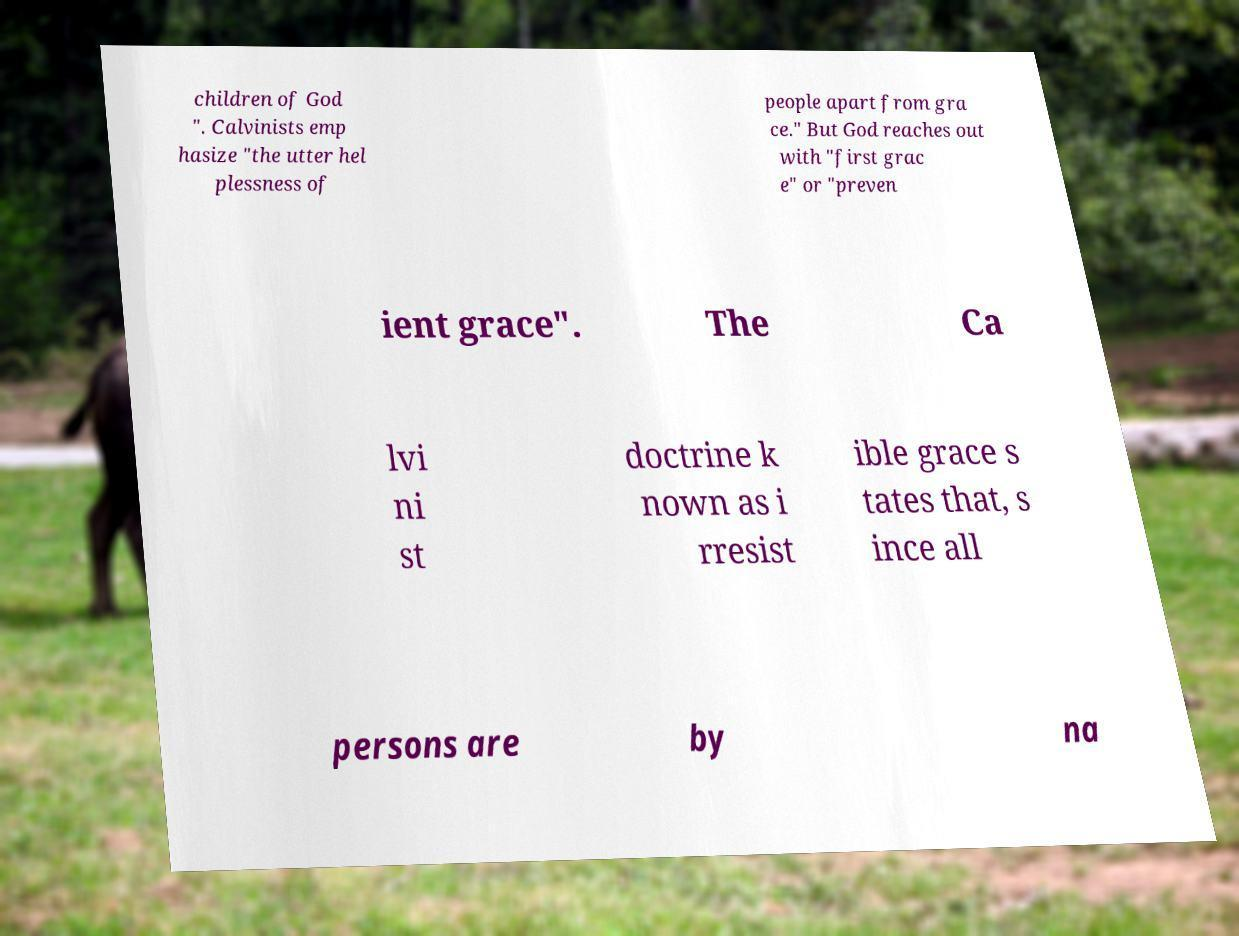Can you accurately transcribe the text from the provided image for me? children of God ". Calvinists emp hasize "the utter hel plessness of people apart from gra ce." But God reaches out with "first grac e" or "preven ient grace". The Ca lvi ni st doctrine k nown as i rresist ible grace s tates that, s ince all persons are by na 